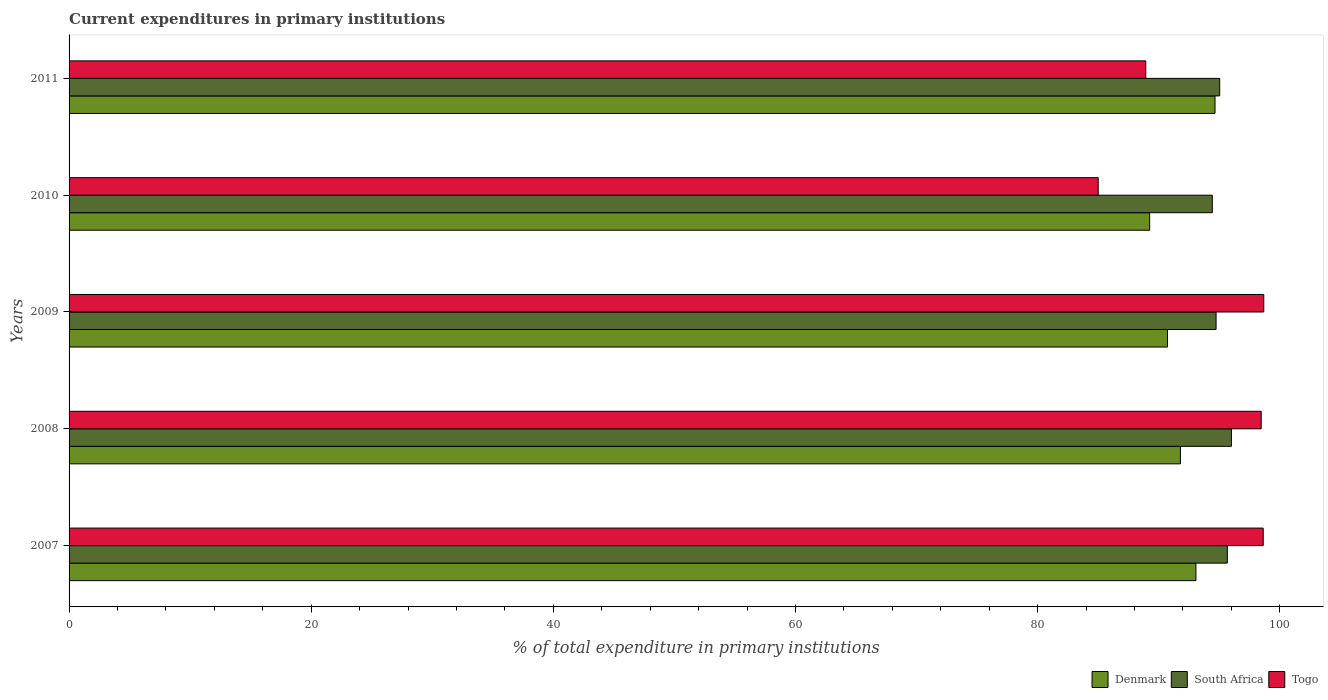How many groups of bars are there?
Make the answer very short. 5. Are the number of bars per tick equal to the number of legend labels?
Keep it short and to the point. Yes. Are the number of bars on each tick of the Y-axis equal?
Offer a terse response. Yes. How many bars are there on the 2nd tick from the top?
Offer a very short reply. 3. What is the current expenditures in primary institutions in South Africa in 2009?
Provide a succinct answer. 94.73. Across all years, what is the maximum current expenditures in primary institutions in Togo?
Your answer should be very brief. 98.67. Across all years, what is the minimum current expenditures in primary institutions in Togo?
Keep it short and to the point. 85. What is the total current expenditures in primary institutions in Denmark in the graph?
Keep it short and to the point. 459.47. What is the difference between the current expenditures in primary institutions in South Africa in 2007 and that in 2010?
Offer a very short reply. 1.24. What is the difference between the current expenditures in primary institutions in Togo in 2009 and the current expenditures in primary institutions in South Africa in 2011?
Provide a succinct answer. 3.64. What is the average current expenditures in primary institutions in Denmark per year?
Ensure brevity in your answer.  91.89. In the year 2011, what is the difference between the current expenditures in primary institutions in South Africa and current expenditures in primary institutions in Denmark?
Your response must be concise. 0.39. In how many years, is the current expenditures in primary institutions in South Africa greater than 64 %?
Offer a very short reply. 5. What is the ratio of the current expenditures in primary institutions in South Africa in 2007 to that in 2011?
Provide a succinct answer. 1.01. Is the difference between the current expenditures in primary institutions in South Africa in 2007 and 2011 greater than the difference between the current expenditures in primary institutions in Denmark in 2007 and 2011?
Offer a very short reply. Yes. What is the difference between the highest and the second highest current expenditures in primary institutions in South Africa?
Your answer should be very brief. 0.34. What is the difference between the highest and the lowest current expenditures in primary institutions in Togo?
Ensure brevity in your answer.  13.67. What does the 1st bar from the top in 2010 represents?
Offer a terse response. Togo. What does the 2nd bar from the bottom in 2011 represents?
Offer a very short reply. South Africa. Is it the case that in every year, the sum of the current expenditures in primary institutions in Denmark and current expenditures in primary institutions in Togo is greater than the current expenditures in primary institutions in South Africa?
Your answer should be compact. Yes. How many bars are there?
Offer a very short reply. 15. Are all the bars in the graph horizontal?
Keep it short and to the point. Yes. How many years are there in the graph?
Ensure brevity in your answer.  5. Are the values on the major ticks of X-axis written in scientific E-notation?
Provide a short and direct response. No. Does the graph contain any zero values?
Your answer should be compact. No. Does the graph contain grids?
Offer a very short reply. No. Where does the legend appear in the graph?
Offer a very short reply. Bottom right. How many legend labels are there?
Your response must be concise. 3. What is the title of the graph?
Your answer should be compact. Current expenditures in primary institutions. What is the label or title of the X-axis?
Offer a very short reply. % of total expenditure in primary institutions. What is the label or title of the Y-axis?
Offer a terse response. Years. What is the % of total expenditure in primary institutions in Denmark in 2007?
Your response must be concise. 93.07. What is the % of total expenditure in primary institutions in South Africa in 2007?
Provide a succinct answer. 95.66. What is the % of total expenditure in primary institutions of Togo in 2007?
Give a very brief answer. 98.63. What is the % of total expenditure in primary institutions in Denmark in 2008?
Ensure brevity in your answer.  91.79. What is the % of total expenditure in primary institutions in South Africa in 2008?
Offer a terse response. 96. What is the % of total expenditure in primary institutions of Togo in 2008?
Your response must be concise. 98.46. What is the % of total expenditure in primary institutions of Denmark in 2009?
Your response must be concise. 90.72. What is the % of total expenditure in primary institutions of South Africa in 2009?
Provide a short and direct response. 94.73. What is the % of total expenditure in primary institutions of Togo in 2009?
Offer a terse response. 98.67. What is the % of total expenditure in primary institutions in Denmark in 2010?
Provide a short and direct response. 89.25. What is the % of total expenditure in primary institutions in South Africa in 2010?
Your answer should be very brief. 94.42. What is the % of total expenditure in primary institutions in Togo in 2010?
Provide a short and direct response. 85. What is the % of total expenditure in primary institutions in Denmark in 2011?
Make the answer very short. 94.65. What is the % of total expenditure in primary institutions in South Africa in 2011?
Your answer should be very brief. 95.03. What is the % of total expenditure in primary institutions of Togo in 2011?
Provide a succinct answer. 88.93. Across all years, what is the maximum % of total expenditure in primary institutions in Denmark?
Offer a terse response. 94.65. Across all years, what is the maximum % of total expenditure in primary institutions of South Africa?
Your answer should be compact. 96. Across all years, what is the maximum % of total expenditure in primary institutions of Togo?
Ensure brevity in your answer.  98.67. Across all years, what is the minimum % of total expenditure in primary institutions in Denmark?
Your answer should be very brief. 89.25. Across all years, what is the minimum % of total expenditure in primary institutions of South Africa?
Keep it short and to the point. 94.42. Across all years, what is the minimum % of total expenditure in primary institutions in Togo?
Your answer should be compact. 85. What is the total % of total expenditure in primary institutions of Denmark in the graph?
Offer a very short reply. 459.47. What is the total % of total expenditure in primary institutions of South Africa in the graph?
Provide a short and direct response. 475.85. What is the total % of total expenditure in primary institutions of Togo in the graph?
Your response must be concise. 469.68. What is the difference between the % of total expenditure in primary institutions in Denmark in 2007 and that in 2008?
Offer a very short reply. 1.28. What is the difference between the % of total expenditure in primary institutions in South Africa in 2007 and that in 2008?
Offer a very short reply. -0.34. What is the difference between the % of total expenditure in primary institutions in Togo in 2007 and that in 2008?
Offer a terse response. 0.17. What is the difference between the % of total expenditure in primary institutions of Denmark in 2007 and that in 2009?
Provide a short and direct response. 2.35. What is the difference between the % of total expenditure in primary institutions in South Africa in 2007 and that in 2009?
Provide a succinct answer. 0.93. What is the difference between the % of total expenditure in primary institutions of Togo in 2007 and that in 2009?
Your answer should be compact. -0.04. What is the difference between the % of total expenditure in primary institutions in Denmark in 2007 and that in 2010?
Keep it short and to the point. 3.82. What is the difference between the % of total expenditure in primary institutions of South Africa in 2007 and that in 2010?
Make the answer very short. 1.24. What is the difference between the % of total expenditure in primary institutions in Togo in 2007 and that in 2010?
Your answer should be very brief. 13.63. What is the difference between the % of total expenditure in primary institutions of Denmark in 2007 and that in 2011?
Your answer should be compact. -1.58. What is the difference between the % of total expenditure in primary institutions of South Africa in 2007 and that in 2011?
Keep it short and to the point. 0.63. What is the difference between the % of total expenditure in primary institutions of Togo in 2007 and that in 2011?
Provide a succinct answer. 9.7. What is the difference between the % of total expenditure in primary institutions of Denmark in 2008 and that in 2009?
Your answer should be compact. 1.07. What is the difference between the % of total expenditure in primary institutions in South Africa in 2008 and that in 2009?
Provide a short and direct response. 1.27. What is the difference between the % of total expenditure in primary institutions in Togo in 2008 and that in 2009?
Make the answer very short. -0.21. What is the difference between the % of total expenditure in primary institutions of Denmark in 2008 and that in 2010?
Make the answer very short. 2.54. What is the difference between the % of total expenditure in primary institutions of South Africa in 2008 and that in 2010?
Offer a terse response. 1.58. What is the difference between the % of total expenditure in primary institutions of Togo in 2008 and that in 2010?
Give a very brief answer. 13.46. What is the difference between the % of total expenditure in primary institutions in Denmark in 2008 and that in 2011?
Offer a terse response. -2.86. What is the difference between the % of total expenditure in primary institutions in South Africa in 2008 and that in 2011?
Keep it short and to the point. 0.97. What is the difference between the % of total expenditure in primary institutions of Togo in 2008 and that in 2011?
Ensure brevity in your answer.  9.53. What is the difference between the % of total expenditure in primary institutions of Denmark in 2009 and that in 2010?
Make the answer very short. 1.47. What is the difference between the % of total expenditure in primary institutions in South Africa in 2009 and that in 2010?
Your answer should be very brief. 0.31. What is the difference between the % of total expenditure in primary institutions of Togo in 2009 and that in 2010?
Provide a succinct answer. 13.67. What is the difference between the % of total expenditure in primary institutions in Denmark in 2009 and that in 2011?
Your response must be concise. -3.93. What is the difference between the % of total expenditure in primary institutions of South Africa in 2009 and that in 2011?
Keep it short and to the point. -0.3. What is the difference between the % of total expenditure in primary institutions in Togo in 2009 and that in 2011?
Your answer should be compact. 9.74. What is the difference between the % of total expenditure in primary institutions of Denmark in 2010 and that in 2011?
Your response must be concise. -5.4. What is the difference between the % of total expenditure in primary institutions in South Africa in 2010 and that in 2011?
Ensure brevity in your answer.  -0.61. What is the difference between the % of total expenditure in primary institutions in Togo in 2010 and that in 2011?
Make the answer very short. -3.93. What is the difference between the % of total expenditure in primary institutions in Denmark in 2007 and the % of total expenditure in primary institutions in South Africa in 2008?
Make the answer very short. -2.93. What is the difference between the % of total expenditure in primary institutions in Denmark in 2007 and the % of total expenditure in primary institutions in Togo in 2008?
Provide a succinct answer. -5.39. What is the difference between the % of total expenditure in primary institutions of South Africa in 2007 and the % of total expenditure in primary institutions of Togo in 2008?
Provide a succinct answer. -2.8. What is the difference between the % of total expenditure in primary institutions of Denmark in 2007 and the % of total expenditure in primary institutions of South Africa in 2009?
Offer a terse response. -1.66. What is the difference between the % of total expenditure in primary institutions in Denmark in 2007 and the % of total expenditure in primary institutions in Togo in 2009?
Give a very brief answer. -5.6. What is the difference between the % of total expenditure in primary institutions in South Africa in 2007 and the % of total expenditure in primary institutions in Togo in 2009?
Provide a short and direct response. -3.01. What is the difference between the % of total expenditure in primary institutions in Denmark in 2007 and the % of total expenditure in primary institutions in South Africa in 2010?
Give a very brief answer. -1.35. What is the difference between the % of total expenditure in primary institutions of Denmark in 2007 and the % of total expenditure in primary institutions of Togo in 2010?
Your answer should be compact. 8.07. What is the difference between the % of total expenditure in primary institutions of South Africa in 2007 and the % of total expenditure in primary institutions of Togo in 2010?
Provide a short and direct response. 10.66. What is the difference between the % of total expenditure in primary institutions of Denmark in 2007 and the % of total expenditure in primary institutions of South Africa in 2011?
Your response must be concise. -1.96. What is the difference between the % of total expenditure in primary institutions in Denmark in 2007 and the % of total expenditure in primary institutions in Togo in 2011?
Make the answer very short. 4.14. What is the difference between the % of total expenditure in primary institutions of South Africa in 2007 and the % of total expenditure in primary institutions of Togo in 2011?
Give a very brief answer. 6.74. What is the difference between the % of total expenditure in primary institutions of Denmark in 2008 and the % of total expenditure in primary institutions of South Africa in 2009?
Your answer should be compact. -2.95. What is the difference between the % of total expenditure in primary institutions in Denmark in 2008 and the % of total expenditure in primary institutions in Togo in 2009?
Offer a very short reply. -6.88. What is the difference between the % of total expenditure in primary institutions in South Africa in 2008 and the % of total expenditure in primary institutions in Togo in 2009?
Provide a succinct answer. -2.67. What is the difference between the % of total expenditure in primary institutions of Denmark in 2008 and the % of total expenditure in primary institutions of South Africa in 2010?
Provide a succinct answer. -2.63. What is the difference between the % of total expenditure in primary institutions of Denmark in 2008 and the % of total expenditure in primary institutions of Togo in 2010?
Your response must be concise. 6.79. What is the difference between the % of total expenditure in primary institutions of South Africa in 2008 and the % of total expenditure in primary institutions of Togo in 2010?
Provide a short and direct response. 11. What is the difference between the % of total expenditure in primary institutions in Denmark in 2008 and the % of total expenditure in primary institutions in South Africa in 2011?
Give a very brief answer. -3.24. What is the difference between the % of total expenditure in primary institutions of Denmark in 2008 and the % of total expenditure in primary institutions of Togo in 2011?
Offer a terse response. 2.86. What is the difference between the % of total expenditure in primary institutions of South Africa in 2008 and the % of total expenditure in primary institutions of Togo in 2011?
Offer a terse response. 7.07. What is the difference between the % of total expenditure in primary institutions in Denmark in 2009 and the % of total expenditure in primary institutions in South Africa in 2010?
Provide a succinct answer. -3.7. What is the difference between the % of total expenditure in primary institutions of Denmark in 2009 and the % of total expenditure in primary institutions of Togo in 2010?
Offer a terse response. 5.72. What is the difference between the % of total expenditure in primary institutions of South Africa in 2009 and the % of total expenditure in primary institutions of Togo in 2010?
Offer a very short reply. 9.73. What is the difference between the % of total expenditure in primary institutions of Denmark in 2009 and the % of total expenditure in primary institutions of South Africa in 2011?
Your answer should be compact. -4.31. What is the difference between the % of total expenditure in primary institutions in Denmark in 2009 and the % of total expenditure in primary institutions in Togo in 2011?
Give a very brief answer. 1.79. What is the difference between the % of total expenditure in primary institutions of South Africa in 2009 and the % of total expenditure in primary institutions of Togo in 2011?
Keep it short and to the point. 5.81. What is the difference between the % of total expenditure in primary institutions in Denmark in 2010 and the % of total expenditure in primary institutions in South Africa in 2011?
Provide a short and direct response. -5.78. What is the difference between the % of total expenditure in primary institutions of Denmark in 2010 and the % of total expenditure in primary institutions of Togo in 2011?
Provide a succinct answer. 0.32. What is the difference between the % of total expenditure in primary institutions of South Africa in 2010 and the % of total expenditure in primary institutions of Togo in 2011?
Make the answer very short. 5.5. What is the average % of total expenditure in primary institutions of Denmark per year?
Your response must be concise. 91.89. What is the average % of total expenditure in primary institutions in South Africa per year?
Offer a terse response. 95.17. What is the average % of total expenditure in primary institutions of Togo per year?
Offer a terse response. 93.94. In the year 2007, what is the difference between the % of total expenditure in primary institutions in Denmark and % of total expenditure in primary institutions in South Africa?
Your answer should be compact. -2.59. In the year 2007, what is the difference between the % of total expenditure in primary institutions in Denmark and % of total expenditure in primary institutions in Togo?
Keep it short and to the point. -5.56. In the year 2007, what is the difference between the % of total expenditure in primary institutions of South Africa and % of total expenditure in primary institutions of Togo?
Offer a terse response. -2.96. In the year 2008, what is the difference between the % of total expenditure in primary institutions in Denmark and % of total expenditure in primary institutions in South Africa?
Your response must be concise. -4.21. In the year 2008, what is the difference between the % of total expenditure in primary institutions of Denmark and % of total expenditure in primary institutions of Togo?
Keep it short and to the point. -6.67. In the year 2008, what is the difference between the % of total expenditure in primary institutions in South Africa and % of total expenditure in primary institutions in Togo?
Your answer should be compact. -2.46. In the year 2009, what is the difference between the % of total expenditure in primary institutions in Denmark and % of total expenditure in primary institutions in South Africa?
Provide a short and direct response. -4.01. In the year 2009, what is the difference between the % of total expenditure in primary institutions of Denmark and % of total expenditure in primary institutions of Togo?
Offer a very short reply. -7.95. In the year 2009, what is the difference between the % of total expenditure in primary institutions of South Africa and % of total expenditure in primary institutions of Togo?
Give a very brief answer. -3.94. In the year 2010, what is the difference between the % of total expenditure in primary institutions of Denmark and % of total expenditure in primary institutions of South Africa?
Give a very brief answer. -5.18. In the year 2010, what is the difference between the % of total expenditure in primary institutions of Denmark and % of total expenditure in primary institutions of Togo?
Make the answer very short. 4.25. In the year 2010, what is the difference between the % of total expenditure in primary institutions in South Africa and % of total expenditure in primary institutions in Togo?
Your answer should be very brief. 9.42. In the year 2011, what is the difference between the % of total expenditure in primary institutions of Denmark and % of total expenditure in primary institutions of South Africa?
Your answer should be very brief. -0.39. In the year 2011, what is the difference between the % of total expenditure in primary institutions in Denmark and % of total expenditure in primary institutions in Togo?
Make the answer very short. 5.72. In the year 2011, what is the difference between the % of total expenditure in primary institutions of South Africa and % of total expenditure in primary institutions of Togo?
Offer a terse response. 6.1. What is the ratio of the % of total expenditure in primary institutions of Denmark in 2007 to that in 2008?
Keep it short and to the point. 1.01. What is the ratio of the % of total expenditure in primary institutions of Denmark in 2007 to that in 2009?
Provide a short and direct response. 1.03. What is the ratio of the % of total expenditure in primary institutions in South Africa in 2007 to that in 2009?
Your answer should be very brief. 1.01. What is the ratio of the % of total expenditure in primary institutions of Togo in 2007 to that in 2009?
Your answer should be compact. 1. What is the ratio of the % of total expenditure in primary institutions in Denmark in 2007 to that in 2010?
Give a very brief answer. 1.04. What is the ratio of the % of total expenditure in primary institutions of South Africa in 2007 to that in 2010?
Offer a terse response. 1.01. What is the ratio of the % of total expenditure in primary institutions of Togo in 2007 to that in 2010?
Your answer should be compact. 1.16. What is the ratio of the % of total expenditure in primary institutions of Denmark in 2007 to that in 2011?
Your response must be concise. 0.98. What is the ratio of the % of total expenditure in primary institutions of South Africa in 2007 to that in 2011?
Your response must be concise. 1.01. What is the ratio of the % of total expenditure in primary institutions in Togo in 2007 to that in 2011?
Keep it short and to the point. 1.11. What is the ratio of the % of total expenditure in primary institutions in Denmark in 2008 to that in 2009?
Give a very brief answer. 1.01. What is the ratio of the % of total expenditure in primary institutions of South Africa in 2008 to that in 2009?
Provide a short and direct response. 1.01. What is the ratio of the % of total expenditure in primary institutions of Togo in 2008 to that in 2009?
Make the answer very short. 1. What is the ratio of the % of total expenditure in primary institutions in Denmark in 2008 to that in 2010?
Offer a very short reply. 1.03. What is the ratio of the % of total expenditure in primary institutions in South Africa in 2008 to that in 2010?
Provide a short and direct response. 1.02. What is the ratio of the % of total expenditure in primary institutions of Togo in 2008 to that in 2010?
Give a very brief answer. 1.16. What is the ratio of the % of total expenditure in primary institutions of Denmark in 2008 to that in 2011?
Your response must be concise. 0.97. What is the ratio of the % of total expenditure in primary institutions of South Africa in 2008 to that in 2011?
Offer a very short reply. 1.01. What is the ratio of the % of total expenditure in primary institutions in Togo in 2008 to that in 2011?
Offer a terse response. 1.11. What is the ratio of the % of total expenditure in primary institutions in Denmark in 2009 to that in 2010?
Offer a very short reply. 1.02. What is the ratio of the % of total expenditure in primary institutions in South Africa in 2009 to that in 2010?
Provide a short and direct response. 1. What is the ratio of the % of total expenditure in primary institutions in Togo in 2009 to that in 2010?
Provide a short and direct response. 1.16. What is the ratio of the % of total expenditure in primary institutions of Denmark in 2009 to that in 2011?
Make the answer very short. 0.96. What is the ratio of the % of total expenditure in primary institutions of Togo in 2009 to that in 2011?
Provide a short and direct response. 1.11. What is the ratio of the % of total expenditure in primary institutions in Denmark in 2010 to that in 2011?
Keep it short and to the point. 0.94. What is the ratio of the % of total expenditure in primary institutions in South Africa in 2010 to that in 2011?
Provide a short and direct response. 0.99. What is the ratio of the % of total expenditure in primary institutions of Togo in 2010 to that in 2011?
Provide a succinct answer. 0.96. What is the difference between the highest and the second highest % of total expenditure in primary institutions in Denmark?
Provide a succinct answer. 1.58. What is the difference between the highest and the second highest % of total expenditure in primary institutions in South Africa?
Make the answer very short. 0.34. What is the difference between the highest and the second highest % of total expenditure in primary institutions in Togo?
Give a very brief answer. 0.04. What is the difference between the highest and the lowest % of total expenditure in primary institutions of Denmark?
Give a very brief answer. 5.4. What is the difference between the highest and the lowest % of total expenditure in primary institutions in South Africa?
Ensure brevity in your answer.  1.58. What is the difference between the highest and the lowest % of total expenditure in primary institutions of Togo?
Keep it short and to the point. 13.67. 